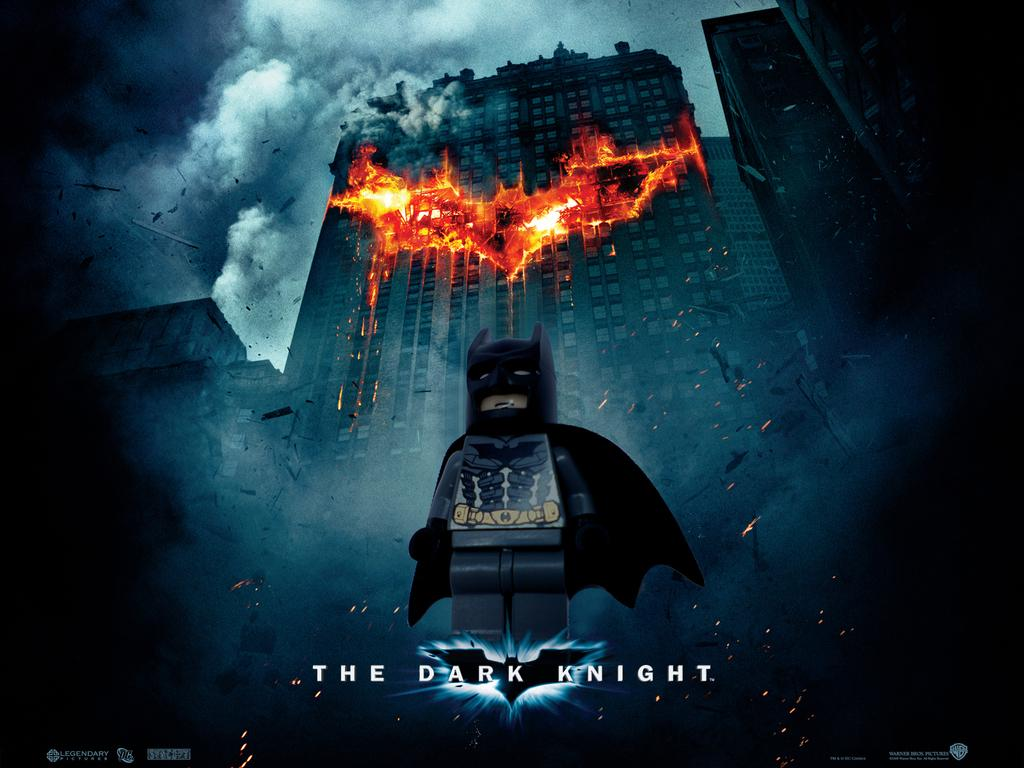<image>
Give a short and clear explanation of the subsequent image. A poster that says The Dark Knight with Lego Batman standing in front of a burning building. 